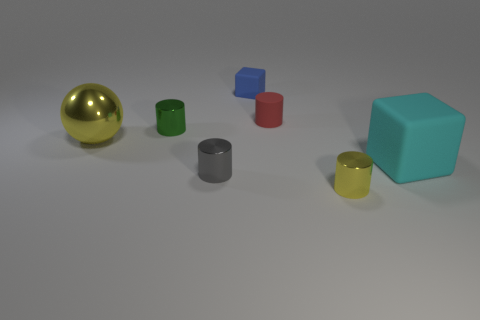Subtract all matte cylinders. How many cylinders are left? 3 Add 2 yellow balls. How many objects exist? 9 Subtract all yellow cylinders. How many cylinders are left? 3 Subtract all balls. How many objects are left? 6 Subtract 3 cylinders. How many cylinders are left? 1 Subtract all gray blocks. Subtract all cyan cylinders. How many blocks are left? 2 Subtract all blue rubber objects. Subtract all tiny green shiny cylinders. How many objects are left? 5 Add 7 tiny green objects. How many tiny green objects are left? 8 Add 5 cylinders. How many cylinders exist? 9 Subtract 1 yellow cylinders. How many objects are left? 6 